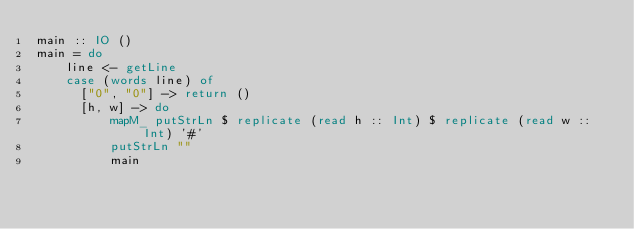<code> <loc_0><loc_0><loc_500><loc_500><_Haskell_>main :: IO ()
main = do
    line <- getLine
    case (words line) of
      ["0", "0"] -> return ()
      [h, w] -> do
          mapM_ putStrLn $ replicate (read h :: Int) $ replicate (read w :: Int) '#'
          putStrLn ""
          main</code> 